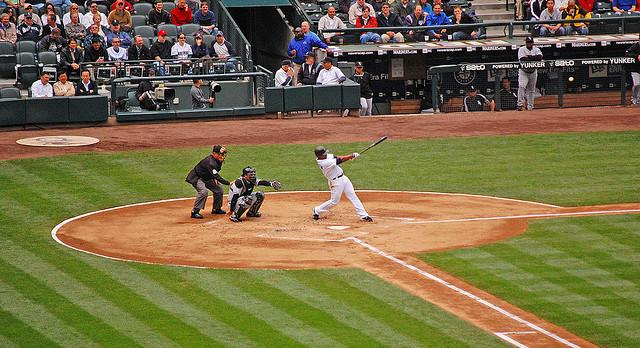Which wood used to make baseball bat?

Choices:
A) ash
B) pine
C) sandal
D) maple maple 